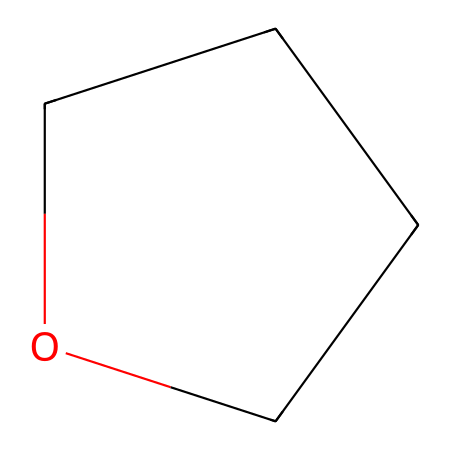What is the total number of carbon atoms in tetrahydrofuran? Tetrahydrofuran has the SMILES representation C1CCOC1, indicating that there are four carbon atoms in the ring.
Answer: 4 How many oxygen atoms are present in tetrahydrofuran? The SMILES representation C1CCOC1 shows one oxygen atom in the structure of tetrahydrofuran.
Answer: 1 What is the type of chemical compound represented by C1CCOC1? The presence of an ether functional group (C-O-C) in the SMILES indicates that tetrahydrofuran belongs to the class of ethers.
Answer: ether What is the molecular formula of tetrahydrofuran? The structure represented by C1CCOC1 gives a total of four carbons, eight hydrogens, and one oxygen, resulting in the molecular formula C4H8O.
Answer: C4H8O Why is tetrahydrofuran considered an acceptable solvent in industrial adhesives? Tetrahydrofuran's structure allows it to be polar and capable of dissolving both polar and non-polar substances, making it effective for use in adhesives.
Answer: polar solvent What type of functional groups are present in tetrahydrofuran? The SMILES representation C1CCOC1 shows an ether functional group as it contains an oxygen atom bonded to two carbon atoms, classifying it as an ether.
Answer: ether Can tetrahydrofuran form hydrogen bonds? Tetrahydrofuran has an oxygen atom, which can participate in hydrogen bonding due to its electronegativity, allowing it to form hydrogen bonds with other molecules.
Answer: yes 